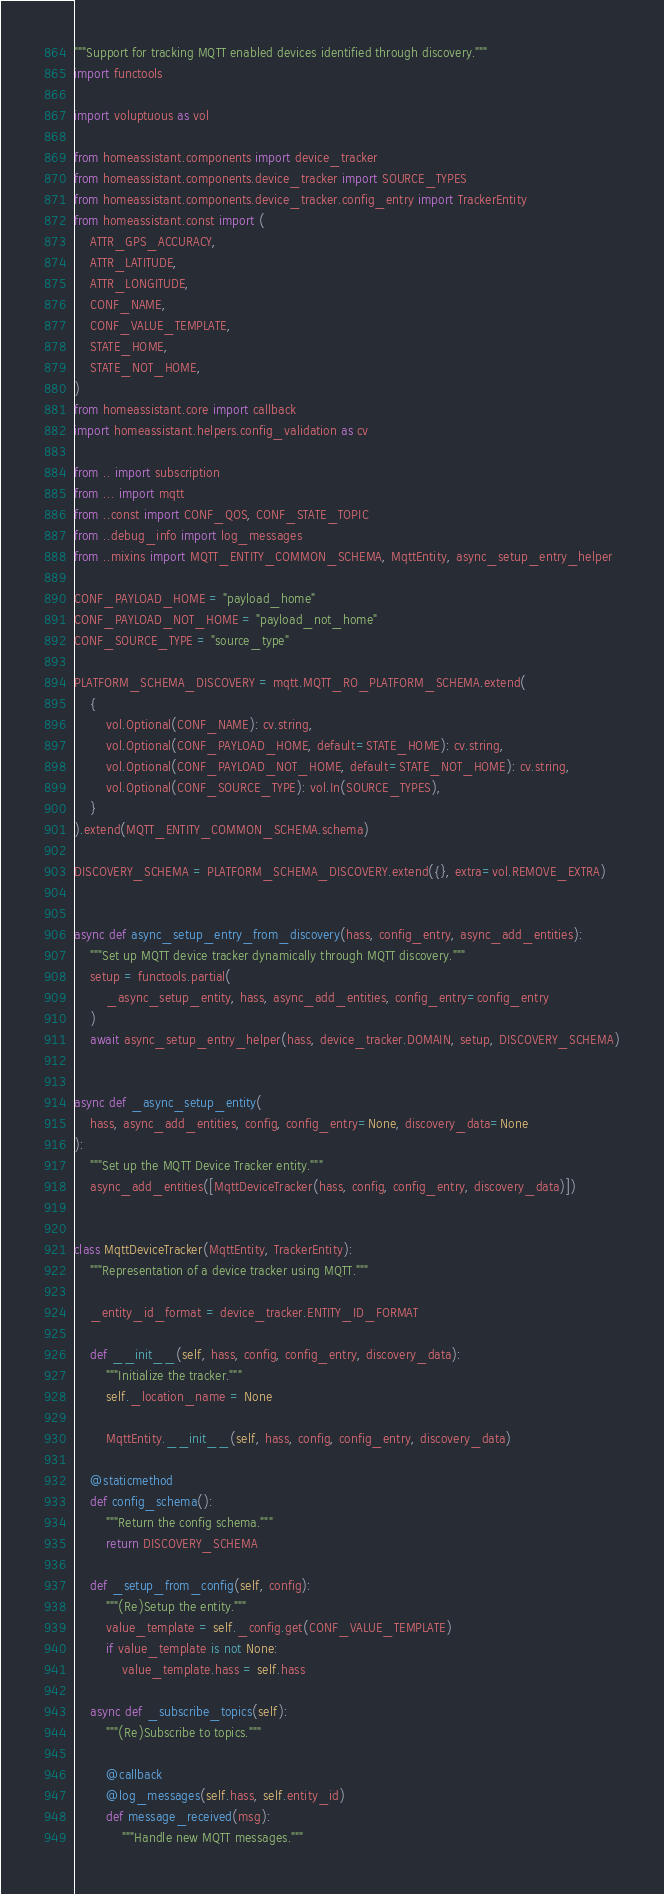Convert code to text. <code><loc_0><loc_0><loc_500><loc_500><_Python_>"""Support for tracking MQTT enabled devices identified through discovery."""
import functools

import voluptuous as vol

from homeassistant.components import device_tracker
from homeassistant.components.device_tracker import SOURCE_TYPES
from homeassistant.components.device_tracker.config_entry import TrackerEntity
from homeassistant.const import (
    ATTR_GPS_ACCURACY,
    ATTR_LATITUDE,
    ATTR_LONGITUDE,
    CONF_NAME,
    CONF_VALUE_TEMPLATE,
    STATE_HOME,
    STATE_NOT_HOME,
)
from homeassistant.core import callback
import homeassistant.helpers.config_validation as cv

from .. import subscription
from ... import mqtt
from ..const import CONF_QOS, CONF_STATE_TOPIC
from ..debug_info import log_messages
from ..mixins import MQTT_ENTITY_COMMON_SCHEMA, MqttEntity, async_setup_entry_helper

CONF_PAYLOAD_HOME = "payload_home"
CONF_PAYLOAD_NOT_HOME = "payload_not_home"
CONF_SOURCE_TYPE = "source_type"

PLATFORM_SCHEMA_DISCOVERY = mqtt.MQTT_RO_PLATFORM_SCHEMA.extend(
    {
        vol.Optional(CONF_NAME): cv.string,
        vol.Optional(CONF_PAYLOAD_HOME, default=STATE_HOME): cv.string,
        vol.Optional(CONF_PAYLOAD_NOT_HOME, default=STATE_NOT_HOME): cv.string,
        vol.Optional(CONF_SOURCE_TYPE): vol.In(SOURCE_TYPES),
    }
).extend(MQTT_ENTITY_COMMON_SCHEMA.schema)

DISCOVERY_SCHEMA = PLATFORM_SCHEMA_DISCOVERY.extend({}, extra=vol.REMOVE_EXTRA)


async def async_setup_entry_from_discovery(hass, config_entry, async_add_entities):
    """Set up MQTT device tracker dynamically through MQTT discovery."""
    setup = functools.partial(
        _async_setup_entity, hass, async_add_entities, config_entry=config_entry
    )
    await async_setup_entry_helper(hass, device_tracker.DOMAIN, setup, DISCOVERY_SCHEMA)


async def _async_setup_entity(
    hass, async_add_entities, config, config_entry=None, discovery_data=None
):
    """Set up the MQTT Device Tracker entity."""
    async_add_entities([MqttDeviceTracker(hass, config, config_entry, discovery_data)])


class MqttDeviceTracker(MqttEntity, TrackerEntity):
    """Representation of a device tracker using MQTT."""

    _entity_id_format = device_tracker.ENTITY_ID_FORMAT

    def __init__(self, hass, config, config_entry, discovery_data):
        """Initialize the tracker."""
        self._location_name = None

        MqttEntity.__init__(self, hass, config, config_entry, discovery_data)

    @staticmethod
    def config_schema():
        """Return the config schema."""
        return DISCOVERY_SCHEMA

    def _setup_from_config(self, config):
        """(Re)Setup the entity."""
        value_template = self._config.get(CONF_VALUE_TEMPLATE)
        if value_template is not None:
            value_template.hass = self.hass

    async def _subscribe_topics(self):
        """(Re)Subscribe to topics."""

        @callback
        @log_messages(self.hass, self.entity_id)
        def message_received(msg):
            """Handle new MQTT messages."""</code> 